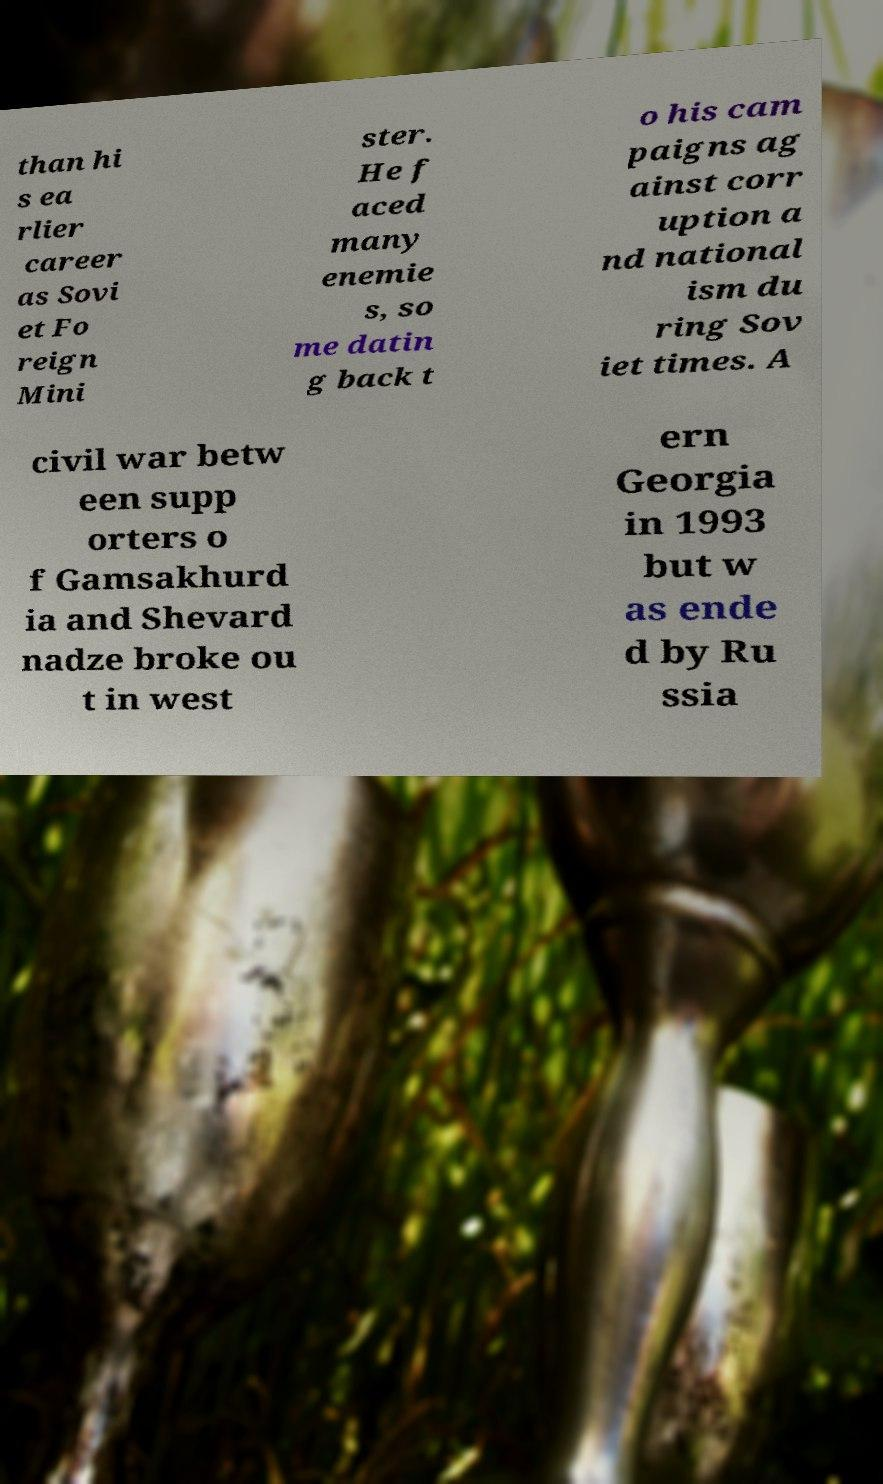For documentation purposes, I need the text within this image transcribed. Could you provide that? than hi s ea rlier career as Sovi et Fo reign Mini ster. He f aced many enemie s, so me datin g back t o his cam paigns ag ainst corr uption a nd national ism du ring Sov iet times. A civil war betw een supp orters o f Gamsakhurd ia and Shevard nadze broke ou t in west ern Georgia in 1993 but w as ende d by Ru ssia 